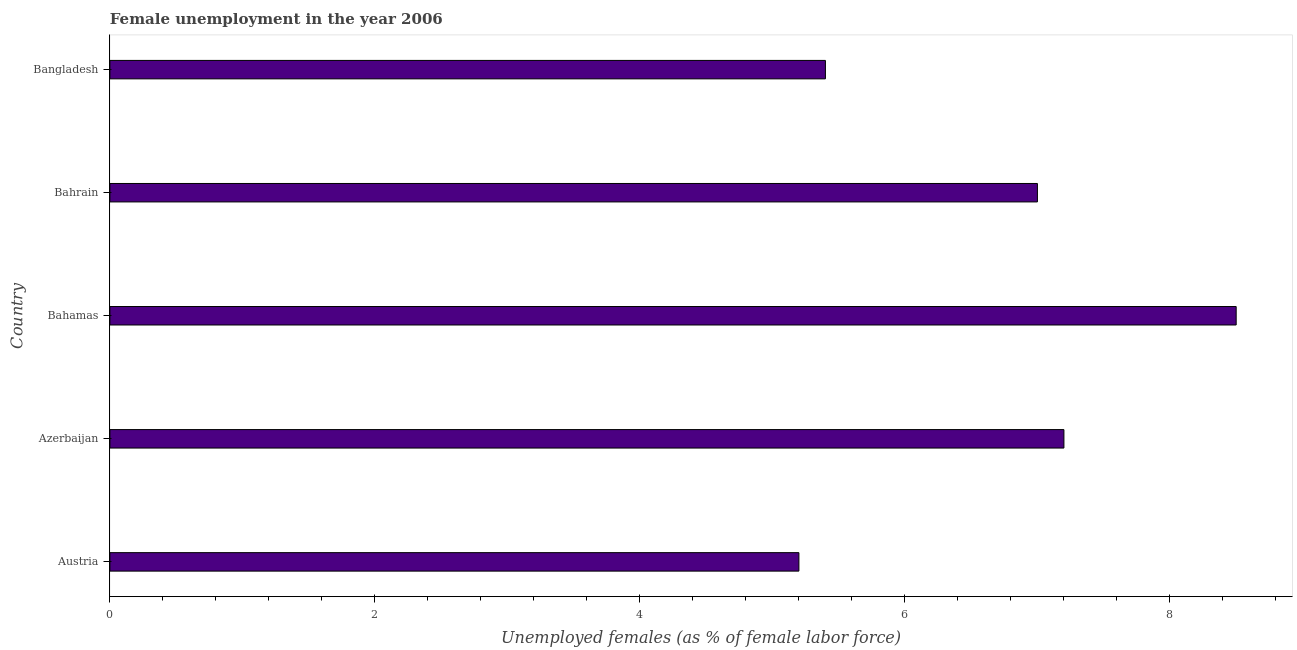What is the title of the graph?
Give a very brief answer. Female unemployment in the year 2006. What is the label or title of the X-axis?
Your answer should be very brief. Unemployed females (as % of female labor force). What is the label or title of the Y-axis?
Provide a succinct answer. Country. What is the unemployed females population in Austria?
Give a very brief answer. 5.2. Across all countries, what is the maximum unemployed females population?
Make the answer very short. 8.5. Across all countries, what is the minimum unemployed females population?
Keep it short and to the point. 5.2. In which country was the unemployed females population maximum?
Make the answer very short. Bahamas. In which country was the unemployed females population minimum?
Your answer should be very brief. Austria. What is the sum of the unemployed females population?
Your answer should be very brief. 33.3. What is the difference between the unemployed females population in Austria and Bahamas?
Provide a short and direct response. -3.3. What is the average unemployed females population per country?
Offer a very short reply. 6.66. What is the ratio of the unemployed females population in Bahamas to that in Bahrain?
Provide a short and direct response. 1.21. Is the unemployed females population in Austria less than that in Bangladesh?
Ensure brevity in your answer.  Yes. What is the difference between the highest and the second highest unemployed females population?
Provide a short and direct response. 1.3. Is the sum of the unemployed females population in Austria and Bangladesh greater than the maximum unemployed females population across all countries?
Offer a terse response. Yes. What is the difference between the highest and the lowest unemployed females population?
Your answer should be compact. 3.3. In how many countries, is the unemployed females population greater than the average unemployed females population taken over all countries?
Make the answer very short. 3. How many bars are there?
Ensure brevity in your answer.  5. What is the Unemployed females (as % of female labor force) of Austria?
Make the answer very short. 5.2. What is the Unemployed females (as % of female labor force) of Azerbaijan?
Give a very brief answer. 7.2. What is the Unemployed females (as % of female labor force) in Bangladesh?
Ensure brevity in your answer.  5.4. What is the difference between the Unemployed females (as % of female labor force) in Austria and Bangladesh?
Keep it short and to the point. -0.2. What is the difference between the Unemployed females (as % of female labor force) in Azerbaijan and Bahrain?
Your answer should be very brief. 0.2. What is the difference between the Unemployed females (as % of female labor force) in Bahamas and Bahrain?
Provide a short and direct response. 1.5. What is the difference between the Unemployed females (as % of female labor force) in Bahamas and Bangladesh?
Ensure brevity in your answer.  3.1. What is the ratio of the Unemployed females (as % of female labor force) in Austria to that in Azerbaijan?
Your answer should be compact. 0.72. What is the ratio of the Unemployed females (as % of female labor force) in Austria to that in Bahamas?
Make the answer very short. 0.61. What is the ratio of the Unemployed females (as % of female labor force) in Austria to that in Bahrain?
Offer a terse response. 0.74. What is the ratio of the Unemployed females (as % of female labor force) in Austria to that in Bangladesh?
Give a very brief answer. 0.96. What is the ratio of the Unemployed females (as % of female labor force) in Azerbaijan to that in Bahamas?
Provide a short and direct response. 0.85. What is the ratio of the Unemployed females (as % of female labor force) in Azerbaijan to that in Bahrain?
Offer a terse response. 1.03. What is the ratio of the Unemployed females (as % of female labor force) in Azerbaijan to that in Bangladesh?
Offer a terse response. 1.33. What is the ratio of the Unemployed females (as % of female labor force) in Bahamas to that in Bahrain?
Keep it short and to the point. 1.21. What is the ratio of the Unemployed females (as % of female labor force) in Bahamas to that in Bangladesh?
Provide a succinct answer. 1.57. What is the ratio of the Unemployed females (as % of female labor force) in Bahrain to that in Bangladesh?
Provide a succinct answer. 1.3. 